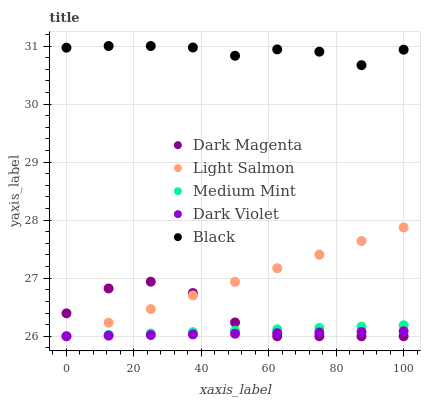Does Dark Violet have the minimum area under the curve?
Answer yes or no. Yes. Does Black have the maximum area under the curve?
Answer yes or no. Yes. Does Light Salmon have the minimum area under the curve?
Answer yes or no. No. Does Light Salmon have the maximum area under the curve?
Answer yes or no. No. Is Medium Mint the smoothest?
Answer yes or no. Yes. Is Dark Magenta the roughest?
Answer yes or no. Yes. Is Light Salmon the smoothest?
Answer yes or no. No. Is Light Salmon the roughest?
Answer yes or no. No. Does Medium Mint have the lowest value?
Answer yes or no. Yes. Does Black have the lowest value?
Answer yes or no. No. Does Black have the highest value?
Answer yes or no. Yes. Does Light Salmon have the highest value?
Answer yes or no. No. Is Light Salmon less than Black?
Answer yes or no. Yes. Is Black greater than Light Salmon?
Answer yes or no. Yes. Does Light Salmon intersect Dark Violet?
Answer yes or no. Yes. Is Light Salmon less than Dark Violet?
Answer yes or no. No. Is Light Salmon greater than Dark Violet?
Answer yes or no. No. Does Light Salmon intersect Black?
Answer yes or no. No. 